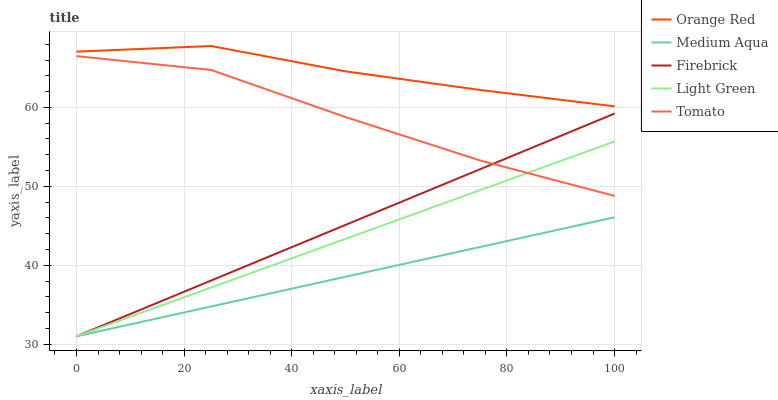Does Firebrick have the minimum area under the curve?
Answer yes or no. No. Does Firebrick have the maximum area under the curve?
Answer yes or no. No. Is Medium Aqua the smoothest?
Answer yes or no. No. Is Medium Aqua the roughest?
Answer yes or no. No. Does Orange Red have the lowest value?
Answer yes or no. No. Does Firebrick have the highest value?
Answer yes or no. No. Is Tomato less than Orange Red?
Answer yes or no. Yes. Is Orange Red greater than Light Green?
Answer yes or no. Yes. Does Tomato intersect Orange Red?
Answer yes or no. No. 